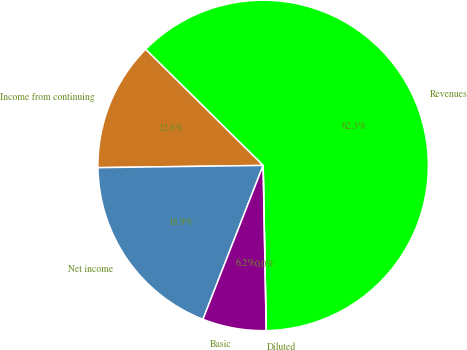Convert chart. <chart><loc_0><loc_0><loc_500><loc_500><pie_chart><fcel>Revenues<fcel>Income from continuing<fcel>Net income<fcel>Basic<fcel>Diluted<nl><fcel>62.3%<fcel>12.62%<fcel>18.85%<fcel>6.23%<fcel>0.0%<nl></chart> 